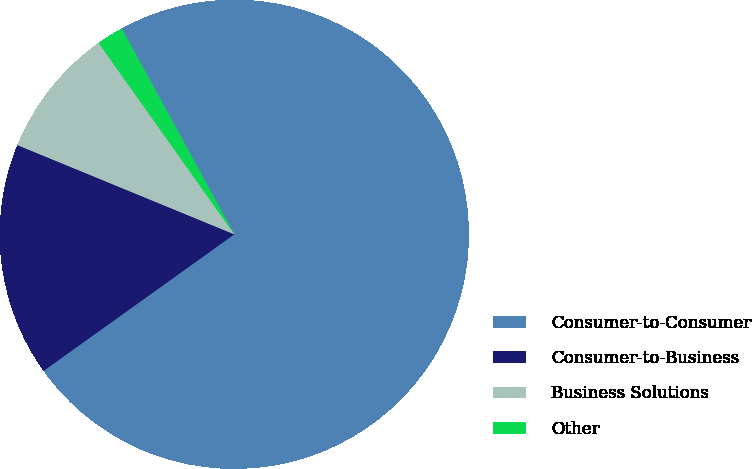Convert chart. <chart><loc_0><loc_0><loc_500><loc_500><pie_chart><fcel>Consumer-to-Consumer<fcel>Consumer-to-Business<fcel>Business Solutions<fcel>Other<nl><fcel>73.08%<fcel>16.1%<fcel>8.97%<fcel>1.85%<nl></chart> 